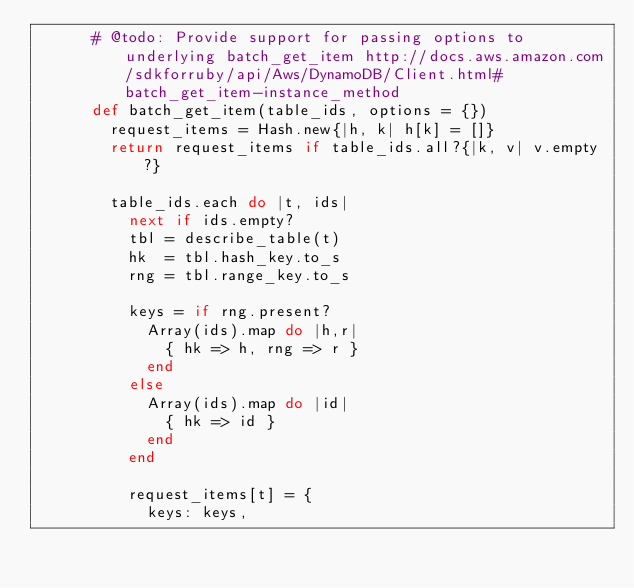Convert code to text. <code><loc_0><loc_0><loc_500><loc_500><_Ruby_>      # @todo: Provide support for passing options to underlying batch_get_item http://docs.aws.amazon.com/sdkforruby/api/Aws/DynamoDB/Client.html#batch_get_item-instance_method
      def batch_get_item(table_ids, options = {})
        request_items = Hash.new{|h, k| h[k] = []}
        return request_items if table_ids.all?{|k, v| v.empty?}

        table_ids.each do |t, ids|
          next if ids.empty?
          tbl = describe_table(t)
          hk  = tbl.hash_key.to_s
          rng = tbl.range_key.to_s

          keys = if rng.present?
            Array(ids).map do |h,r|
              { hk => h, rng => r }
            end
          else
            Array(ids).map do |id|
              { hk => id }
            end
          end

          request_items[t] = {
            keys: keys,</code> 